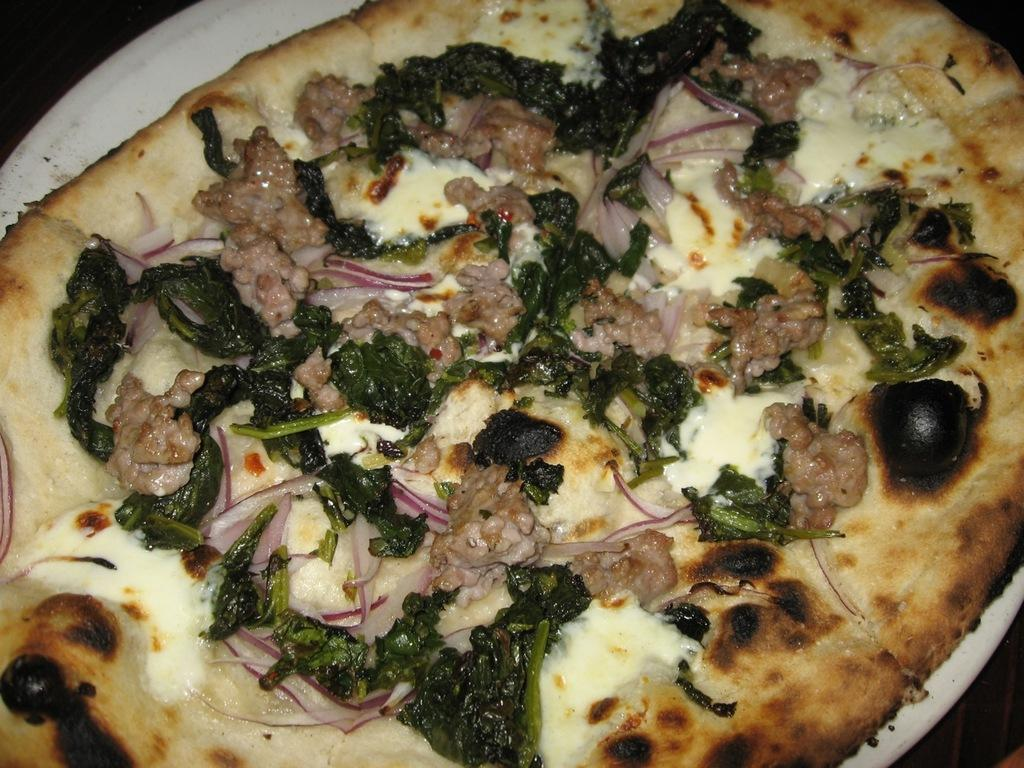What type of food is the main subject in the image? There is a pizza in the image. How is the pizza presented in the image? The pizza is on a plate. What type of story is being told on the paper in the image? There is no paper present in the image, and therefore no story can be observed. What kind of horn is visible in the image? There is no horn present in the image. 